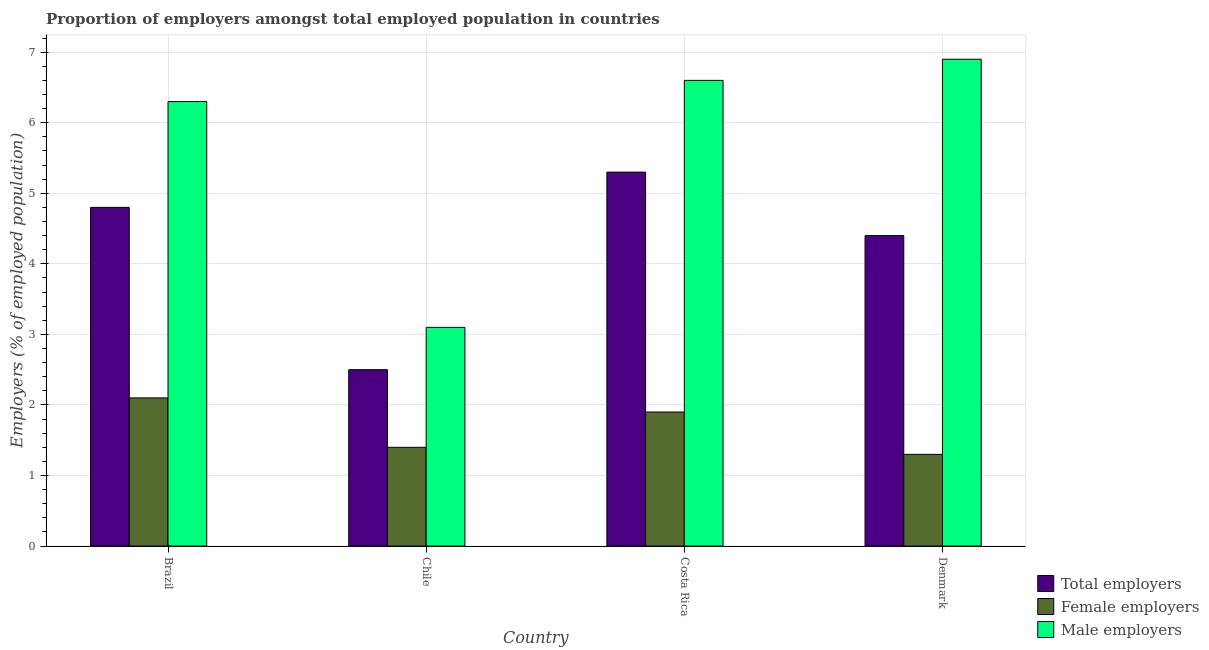How many different coloured bars are there?
Give a very brief answer. 3. How many groups of bars are there?
Your response must be concise. 4. How many bars are there on the 3rd tick from the left?
Offer a very short reply. 3. What is the label of the 2nd group of bars from the left?
Your response must be concise. Chile. In how many cases, is the number of bars for a given country not equal to the number of legend labels?
Provide a short and direct response. 0. What is the percentage of female employers in Costa Rica?
Offer a terse response. 1.9. Across all countries, what is the maximum percentage of female employers?
Offer a very short reply. 2.1. Across all countries, what is the minimum percentage of female employers?
Make the answer very short. 1.3. In which country was the percentage of female employers minimum?
Make the answer very short. Denmark. What is the total percentage of total employers in the graph?
Provide a succinct answer. 17. What is the difference between the percentage of total employers in Brazil and that in Chile?
Give a very brief answer. 2.3. What is the difference between the percentage of male employers in Chile and the percentage of female employers in Costa Rica?
Make the answer very short. 1.2. What is the average percentage of total employers per country?
Your answer should be very brief. 4.25. What is the difference between the percentage of male employers and percentage of female employers in Chile?
Your response must be concise. 1.7. In how many countries, is the percentage of female employers greater than 6.4 %?
Provide a short and direct response. 0. What is the ratio of the percentage of male employers in Costa Rica to that in Denmark?
Offer a very short reply. 0.96. Is the percentage of total employers in Costa Rica less than that in Denmark?
Provide a succinct answer. No. What is the difference between the highest and the second highest percentage of male employers?
Provide a short and direct response. 0.3. What is the difference between the highest and the lowest percentage of total employers?
Your answer should be very brief. 2.8. In how many countries, is the percentage of male employers greater than the average percentage of male employers taken over all countries?
Give a very brief answer. 3. What does the 3rd bar from the left in Denmark represents?
Make the answer very short. Male employers. What does the 1st bar from the right in Brazil represents?
Your answer should be compact. Male employers. Is it the case that in every country, the sum of the percentage of total employers and percentage of female employers is greater than the percentage of male employers?
Make the answer very short. No. How many bars are there?
Provide a short and direct response. 12. Are all the bars in the graph horizontal?
Ensure brevity in your answer.  No. How many countries are there in the graph?
Make the answer very short. 4. What is the difference between two consecutive major ticks on the Y-axis?
Give a very brief answer. 1. Does the graph contain any zero values?
Your response must be concise. No. How many legend labels are there?
Ensure brevity in your answer.  3. What is the title of the graph?
Ensure brevity in your answer.  Proportion of employers amongst total employed population in countries. Does "Oil" appear as one of the legend labels in the graph?
Ensure brevity in your answer.  No. What is the label or title of the Y-axis?
Keep it short and to the point. Employers (% of employed population). What is the Employers (% of employed population) in Total employers in Brazil?
Provide a succinct answer. 4.8. What is the Employers (% of employed population) of Female employers in Brazil?
Your response must be concise. 2.1. What is the Employers (% of employed population) in Male employers in Brazil?
Make the answer very short. 6.3. What is the Employers (% of employed population) in Total employers in Chile?
Provide a short and direct response. 2.5. What is the Employers (% of employed population) of Female employers in Chile?
Ensure brevity in your answer.  1.4. What is the Employers (% of employed population) in Male employers in Chile?
Your answer should be very brief. 3.1. What is the Employers (% of employed population) in Total employers in Costa Rica?
Ensure brevity in your answer.  5.3. What is the Employers (% of employed population) in Female employers in Costa Rica?
Offer a very short reply. 1.9. What is the Employers (% of employed population) in Male employers in Costa Rica?
Provide a short and direct response. 6.6. What is the Employers (% of employed population) in Total employers in Denmark?
Provide a short and direct response. 4.4. What is the Employers (% of employed population) in Female employers in Denmark?
Your answer should be very brief. 1.3. What is the Employers (% of employed population) in Male employers in Denmark?
Ensure brevity in your answer.  6.9. Across all countries, what is the maximum Employers (% of employed population) in Total employers?
Offer a very short reply. 5.3. Across all countries, what is the maximum Employers (% of employed population) of Female employers?
Ensure brevity in your answer.  2.1. Across all countries, what is the maximum Employers (% of employed population) of Male employers?
Offer a very short reply. 6.9. Across all countries, what is the minimum Employers (% of employed population) of Total employers?
Keep it short and to the point. 2.5. Across all countries, what is the minimum Employers (% of employed population) of Female employers?
Your answer should be compact. 1.3. Across all countries, what is the minimum Employers (% of employed population) of Male employers?
Keep it short and to the point. 3.1. What is the total Employers (% of employed population) of Total employers in the graph?
Offer a terse response. 17. What is the total Employers (% of employed population) of Male employers in the graph?
Your answer should be compact. 22.9. What is the difference between the Employers (% of employed population) of Total employers in Brazil and that in Chile?
Offer a very short reply. 2.3. What is the difference between the Employers (% of employed population) of Female employers in Brazil and that in Chile?
Offer a very short reply. 0.7. What is the difference between the Employers (% of employed population) in Male employers in Brazil and that in Chile?
Your answer should be very brief. 3.2. What is the difference between the Employers (% of employed population) in Total employers in Brazil and that in Costa Rica?
Ensure brevity in your answer.  -0.5. What is the difference between the Employers (% of employed population) in Male employers in Brazil and that in Costa Rica?
Provide a short and direct response. -0.3. What is the difference between the Employers (% of employed population) in Total employers in Brazil and that in Denmark?
Ensure brevity in your answer.  0.4. What is the difference between the Employers (% of employed population) in Male employers in Chile and that in Costa Rica?
Ensure brevity in your answer.  -3.5. What is the difference between the Employers (% of employed population) in Total employers in Chile and that in Denmark?
Keep it short and to the point. -1.9. What is the difference between the Employers (% of employed population) of Male employers in Costa Rica and that in Denmark?
Make the answer very short. -0.3. What is the difference between the Employers (% of employed population) of Total employers in Brazil and the Employers (% of employed population) of Female employers in Costa Rica?
Keep it short and to the point. 2.9. What is the difference between the Employers (% of employed population) of Female employers in Brazil and the Employers (% of employed population) of Male employers in Costa Rica?
Give a very brief answer. -4.5. What is the difference between the Employers (% of employed population) in Total employers in Brazil and the Employers (% of employed population) in Female employers in Denmark?
Provide a succinct answer. 3.5. What is the difference between the Employers (% of employed population) of Total employers in Brazil and the Employers (% of employed population) of Male employers in Denmark?
Make the answer very short. -2.1. What is the difference between the Employers (% of employed population) in Female employers in Brazil and the Employers (% of employed population) in Male employers in Denmark?
Provide a succinct answer. -4.8. What is the difference between the Employers (% of employed population) of Total employers in Chile and the Employers (% of employed population) of Female employers in Costa Rica?
Keep it short and to the point. 0.6. What is the difference between the Employers (% of employed population) of Total employers in Chile and the Employers (% of employed population) of Male employers in Costa Rica?
Offer a terse response. -4.1. What is the difference between the Employers (% of employed population) in Female employers in Chile and the Employers (% of employed population) in Male employers in Costa Rica?
Provide a succinct answer. -5.2. What is the difference between the Employers (% of employed population) in Total employers in Chile and the Employers (% of employed population) in Male employers in Denmark?
Offer a terse response. -4.4. What is the difference between the Employers (% of employed population) in Female employers in Chile and the Employers (% of employed population) in Male employers in Denmark?
Provide a succinct answer. -5.5. What is the difference between the Employers (% of employed population) of Total employers in Costa Rica and the Employers (% of employed population) of Male employers in Denmark?
Keep it short and to the point. -1.6. What is the difference between the Employers (% of employed population) in Female employers in Costa Rica and the Employers (% of employed population) in Male employers in Denmark?
Keep it short and to the point. -5. What is the average Employers (% of employed population) in Total employers per country?
Your answer should be very brief. 4.25. What is the average Employers (% of employed population) in Female employers per country?
Your response must be concise. 1.68. What is the average Employers (% of employed population) in Male employers per country?
Provide a short and direct response. 5.72. What is the difference between the Employers (% of employed population) of Total employers and Employers (% of employed population) of Female employers in Brazil?
Provide a short and direct response. 2.7. What is the difference between the Employers (% of employed population) of Female employers and Employers (% of employed population) of Male employers in Brazil?
Give a very brief answer. -4.2. What is the difference between the Employers (% of employed population) of Female employers and Employers (% of employed population) of Male employers in Chile?
Your response must be concise. -1.7. What is the difference between the Employers (% of employed population) in Total employers and Employers (% of employed population) in Male employers in Costa Rica?
Give a very brief answer. -1.3. What is the difference between the Employers (% of employed population) of Total employers and Employers (% of employed population) of Female employers in Denmark?
Keep it short and to the point. 3.1. What is the difference between the Employers (% of employed population) in Female employers and Employers (% of employed population) in Male employers in Denmark?
Provide a short and direct response. -5.6. What is the ratio of the Employers (% of employed population) in Total employers in Brazil to that in Chile?
Keep it short and to the point. 1.92. What is the ratio of the Employers (% of employed population) in Female employers in Brazil to that in Chile?
Offer a terse response. 1.5. What is the ratio of the Employers (% of employed population) of Male employers in Brazil to that in Chile?
Your answer should be very brief. 2.03. What is the ratio of the Employers (% of employed population) in Total employers in Brazil to that in Costa Rica?
Your answer should be very brief. 0.91. What is the ratio of the Employers (% of employed population) in Female employers in Brazil to that in Costa Rica?
Provide a succinct answer. 1.11. What is the ratio of the Employers (% of employed population) of Male employers in Brazil to that in Costa Rica?
Give a very brief answer. 0.95. What is the ratio of the Employers (% of employed population) in Total employers in Brazil to that in Denmark?
Your answer should be compact. 1.09. What is the ratio of the Employers (% of employed population) of Female employers in Brazil to that in Denmark?
Offer a very short reply. 1.62. What is the ratio of the Employers (% of employed population) of Male employers in Brazil to that in Denmark?
Make the answer very short. 0.91. What is the ratio of the Employers (% of employed population) in Total employers in Chile to that in Costa Rica?
Provide a succinct answer. 0.47. What is the ratio of the Employers (% of employed population) in Female employers in Chile to that in Costa Rica?
Provide a short and direct response. 0.74. What is the ratio of the Employers (% of employed population) in Male employers in Chile to that in Costa Rica?
Ensure brevity in your answer.  0.47. What is the ratio of the Employers (% of employed population) in Total employers in Chile to that in Denmark?
Give a very brief answer. 0.57. What is the ratio of the Employers (% of employed population) of Female employers in Chile to that in Denmark?
Your response must be concise. 1.08. What is the ratio of the Employers (% of employed population) in Male employers in Chile to that in Denmark?
Give a very brief answer. 0.45. What is the ratio of the Employers (% of employed population) of Total employers in Costa Rica to that in Denmark?
Ensure brevity in your answer.  1.2. What is the ratio of the Employers (% of employed population) in Female employers in Costa Rica to that in Denmark?
Your answer should be compact. 1.46. What is the ratio of the Employers (% of employed population) in Male employers in Costa Rica to that in Denmark?
Your answer should be compact. 0.96. What is the difference between the highest and the second highest Employers (% of employed population) in Total employers?
Provide a succinct answer. 0.5. What is the difference between the highest and the second highest Employers (% of employed population) of Male employers?
Provide a short and direct response. 0.3. What is the difference between the highest and the lowest Employers (% of employed population) in Female employers?
Your answer should be very brief. 0.8. 